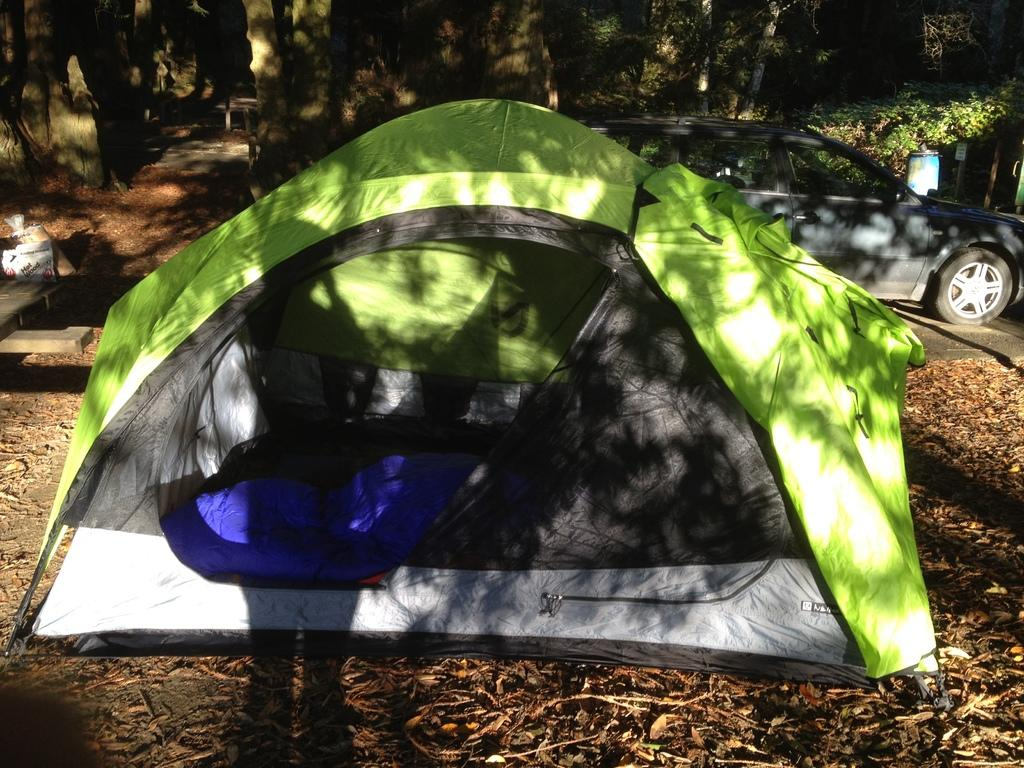What type of terrain is visible in the image? There is ground with dry leaves in the image. What is the nature of the soil in the image? There is rent (possibly meant as "dirt") in the image. What type of transportation can be seen in the image? There is a vehicle in the image. What type of path is visible in the image? There is a road in the image. What type of vegetation is present in the image? There are trees and plants in the image. What objects are present on the left side of the image? There are some objects on the left side of the image. What type of necklace is the partner wearing in the image? There is no partner or necklace present in the image. What type of pipe is visible in the image? There is no pipe present in the image. 